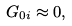<formula> <loc_0><loc_0><loc_500><loc_500>G _ { 0 i } \approx 0 ,</formula> 